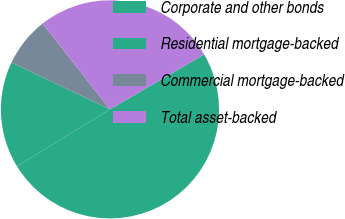Convert chart to OTSL. <chart><loc_0><loc_0><loc_500><loc_500><pie_chart><fcel>Corporate and other bonds<fcel>Residential mortgage-backed<fcel>Commercial mortgage-backed<fcel>Total asset-backed<nl><fcel>49.66%<fcel>15.81%<fcel>7.35%<fcel>27.18%<nl></chart> 